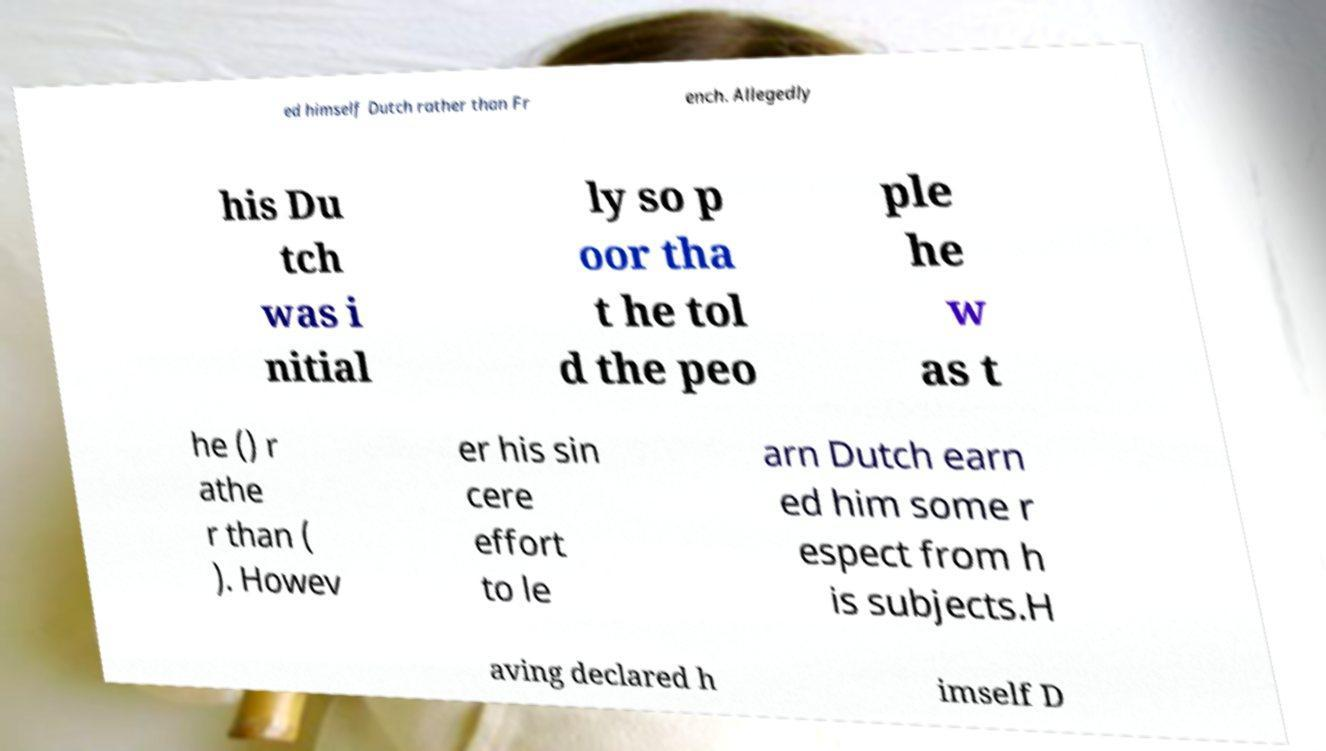What messages or text are displayed in this image? I need them in a readable, typed format. ed himself Dutch rather than Fr ench. Allegedly his Du tch was i nitial ly so p oor tha t he tol d the peo ple he w as t he () r athe r than ( ). Howev er his sin cere effort to le arn Dutch earn ed him some r espect from h is subjects.H aving declared h imself D 